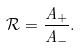Convert formula to latex. <formula><loc_0><loc_0><loc_500><loc_500>\mathcal { R } = { \frac { A _ { + } } { A _ { - } } } .</formula> 